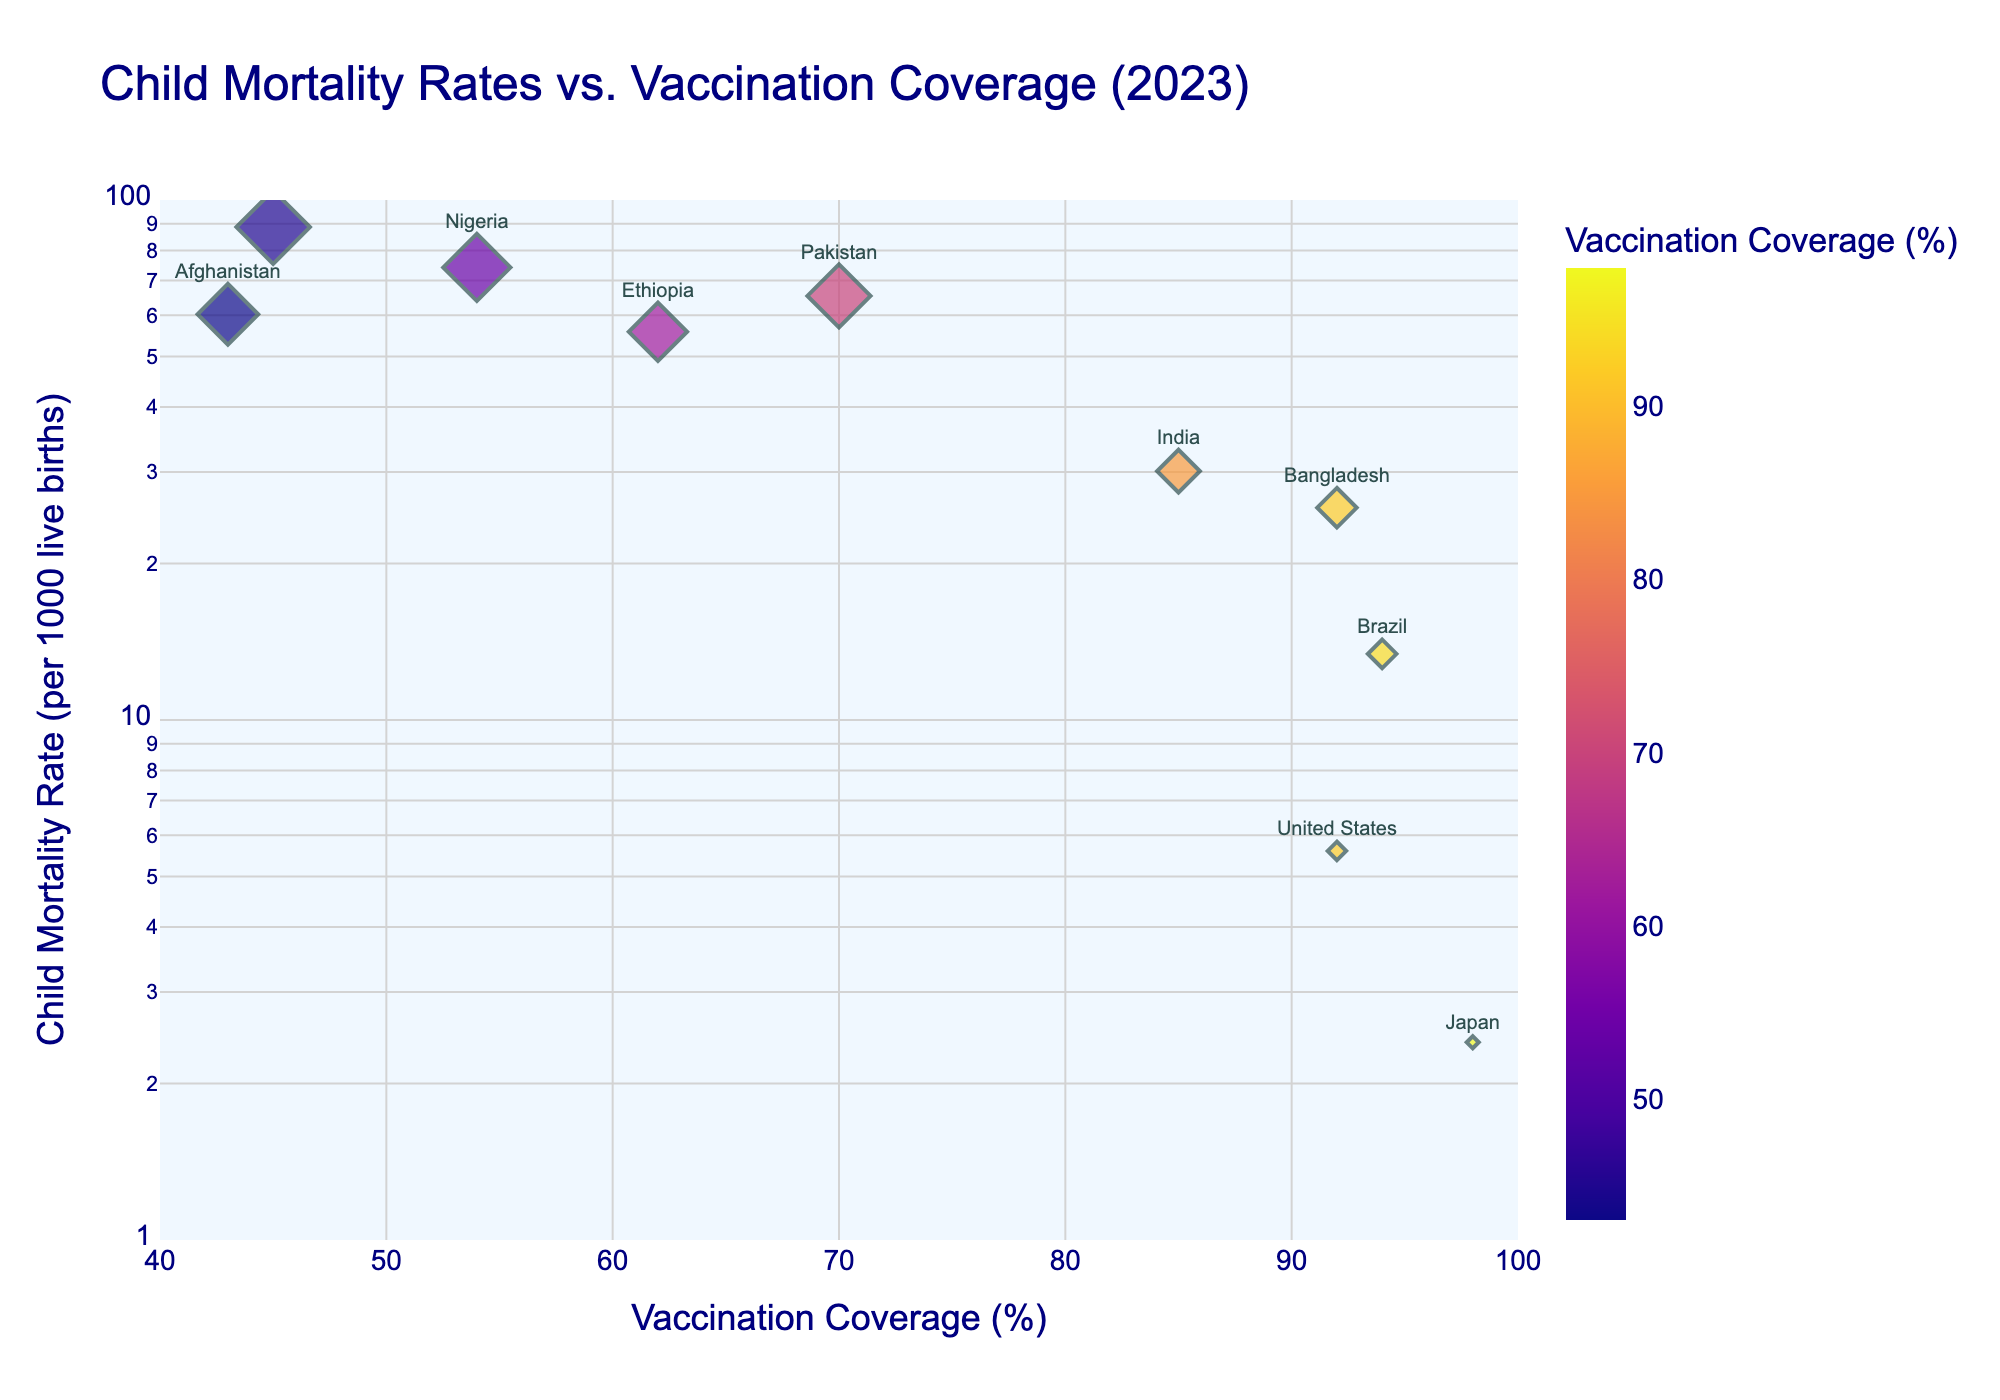What is the title of the plot? The title of the plot is displayed at the top of the figure. It reads the full text "Child Mortality Rates vs. Vaccination Coverage (2023)".
Answer: Child Mortality Rates vs. Vaccination Coverage (2023) Which country has the lowest child mortality rate and what is it? By locating the lowest data point on the y-axis (with 'Child Mortality Rate (per 1000 live births)'), you can identify Japan as the country and the rate of 2.4 per 1000 live births.
Answer: Japan, 2.4 How many countries in the plot have a vaccination coverage of above 90%? Looking at the data points along the x-axis, the countries with greater than 90% vaccination coverage are Brazil, Bangladesh, United States, and Japan, making a total of 4 countries.
Answer: 4 What is the difference in child mortality rates between Nigeria and Bangladesh? From the plot, Nigeria has a child mortality rate of 74.2, and Bangladesh has 25.6. Subtracting the two gives 74.2 - 25.6 = 48.6.
Answer: 48.6 Which countries have both a child mortality rate greater than 50 and vaccination coverage below 50%? Observing the plot indicates that Afghanistan (60.3 mortality, 43% coverage), and the Democratic Republic of the Congo (88.7 mortality, 45% coverage) meet these conditions.
Answer: Afghanistan, Democratic Republic of the Congo How does the child mortality rate in the United States compare to that in Brazil? The plot shows the United States with a child mortality rate of 5.6 and Brazil with 13.4. Therefore, the U.S. has a lower child mortality rate than Brazil.
Answer: The United States has a lower rate than Brazil Between Ethiopia and Pakistan, which country has a higher vaccination coverage? From the plot, Ethiopia shows 62% vaccination coverage, while Pakistan shows 70%. Hence, Pakistan has a higher coverage rate.
Answer: Pakistan What is the sum of the child mortality rates for Afghanistan and Pakistan? Afghanistan has a rate of 60.3, and Pakistan has 65.4. Adding them gives 60.3 + 65.4 = 125.7.
Answer: 125.7 If you were to cluster the countries based on a child mortality rate of 30 per 1000 live births, which countries fall below this threshold? According to the plot, Brazil (13.4), Japan (2.4), and the United States (5.6) fall below the 30 per 1000 live births threshold.
Answer: Brazil, Japan, United States 